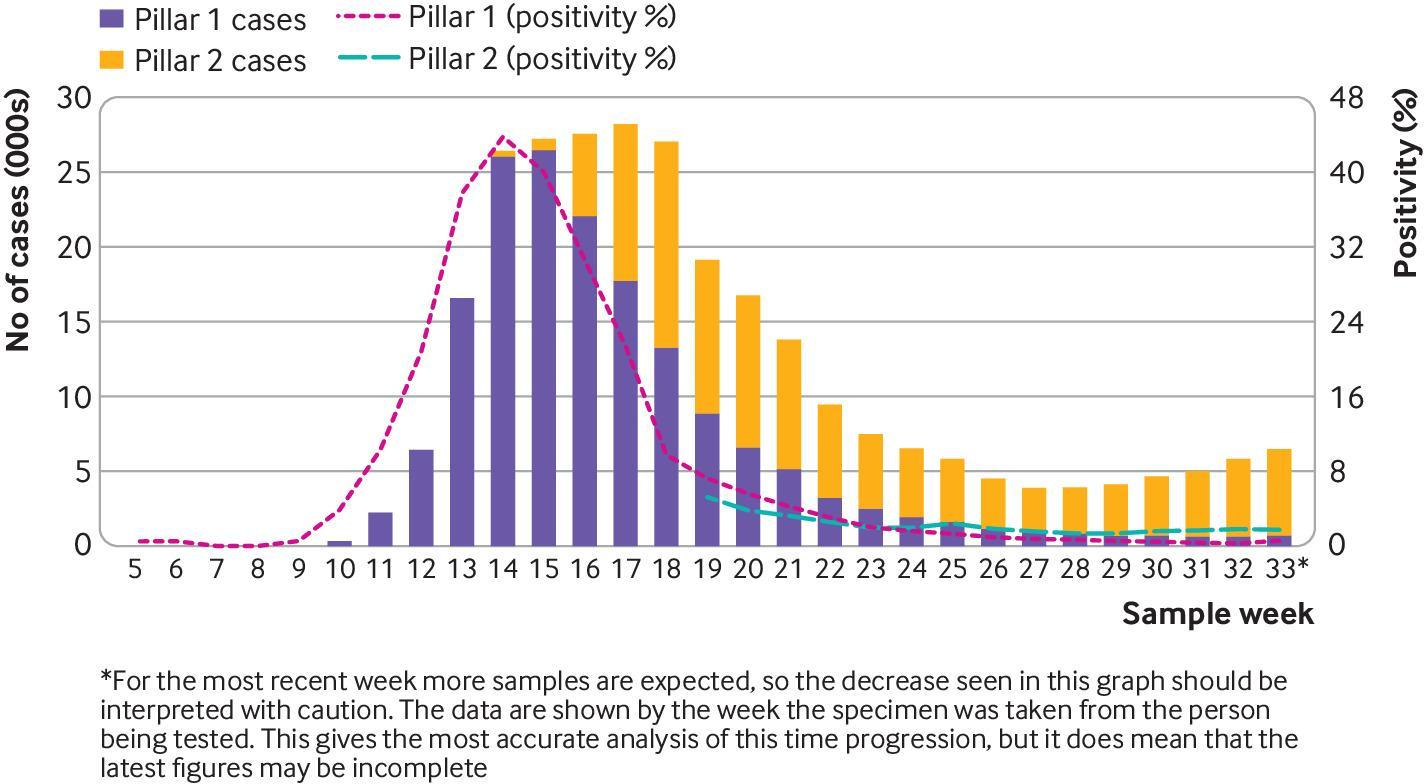What is the total number of cases?
Answer the question with a short phrase. 105 